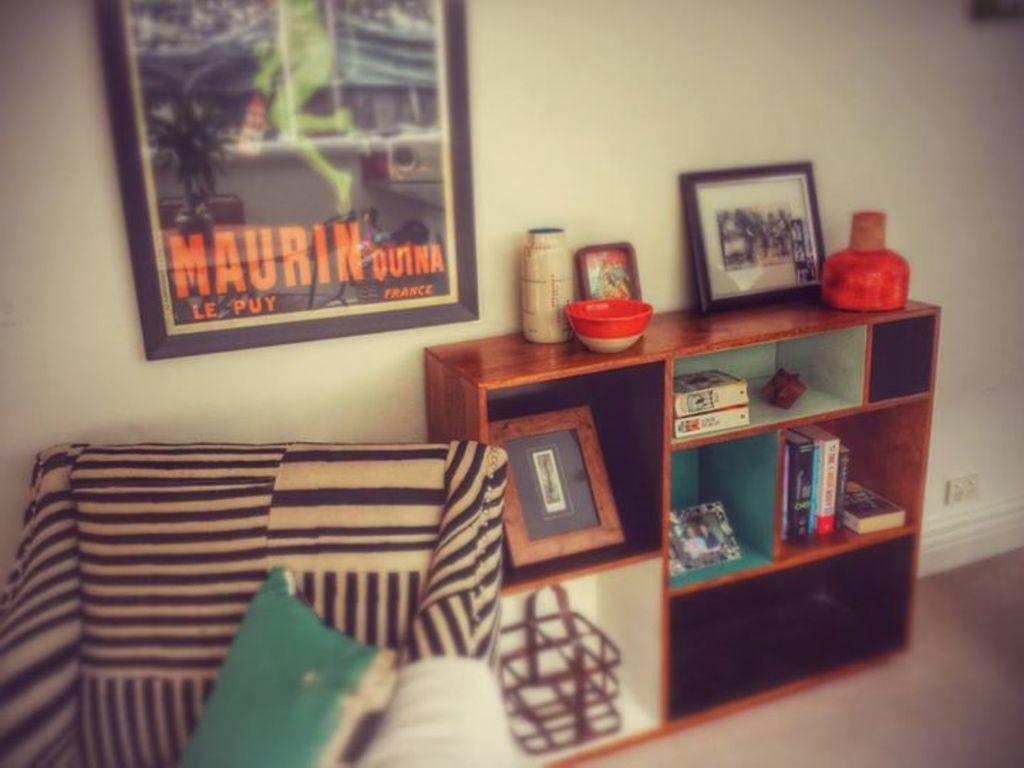<image>
Give a short and clear explanation of the subsequent image. A living room with a poster on a wall that has the word Maurin on it. 